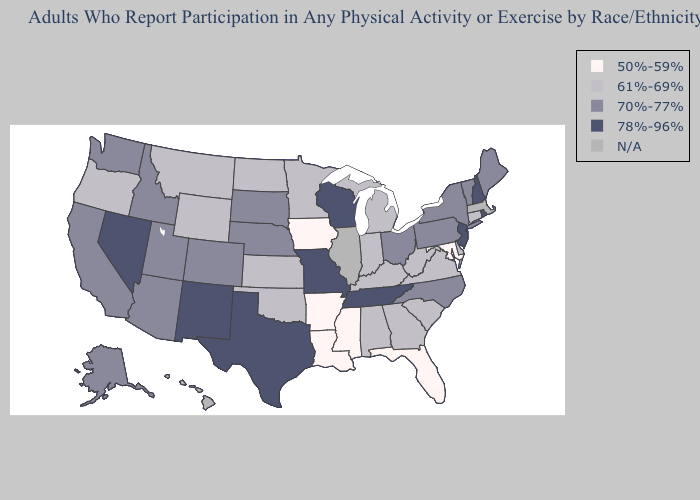Which states have the lowest value in the USA?
Concise answer only. Arkansas, Florida, Iowa, Louisiana, Maryland, Mississippi. Name the states that have a value in the range 61%-69%?
Be succinct. Alabama, Connecticut, Delaware, Georgia, Indiana, Kansas, Kentucky, Michigan, Minnesota, Montana, North Dakota, Oklahoma, Oregon, South Carolina, Virginia, West Virginia, Wyoming. Name the states that have a value in the range N/A?
Short answer required. Hawaii, Illinois, Massachusetts. What is the lowest value in states that border Missouri?
Answer briefly. 50%-59%. Name the states that have a value in the range 78%-96%?
Answer briefly. Missouri, Nevada, New Hampshire, New Jersey, New Mexico, Rhode Island, Tennessee, Texas, Wisconsin. What is the value of Missouri?
Concise answer only. 78%-96%. Among the states that border Kentucky , does Ohio have the lowest value?
Quick response, please. No. What is the lowest value in the USA?
Keep it brief. 50%-59%. Does Florida have the lowest value in the South?
Concise answer only. Yes. Name the states that have a value in the range 78%-96%?
Give a very brief answer. Missouri, Nevada, New Hampshire, New Jersey, New Mexico, Rhode Island, Tennessee, Texas, Wisconsin. Does the map have missing data?
Be succinct. Yes. Is the legend a continuous bar?
Give a very brief answer. No. Name the states that have a value in the range 61%-69%?
Concise answer only. Alabama, Connecticut, Delaware, Georgia, Indiana, Kansas, Kentucky, Michigan, Minnesota, Montana, North Dakota, Oklahoma, Oregon, South Carolina, Virginia, West Virginia, Wyoming. 